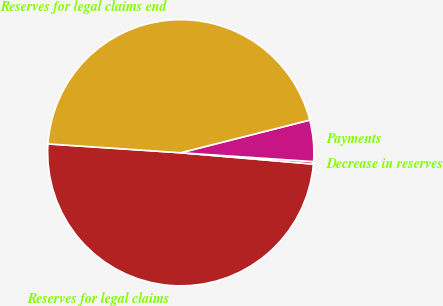<chart> <loc_0><loc_0><loc_500><loc_500><pie_chart><fcel>Reserves for legal claims<fcel>Decrease in reserves<fcel>Payments<fcel>Reserves for legal claims end<nl><fcel>49.7%<fcel>0.3%<fcel>5.01%<fcel>44.99%<nl></chart> 